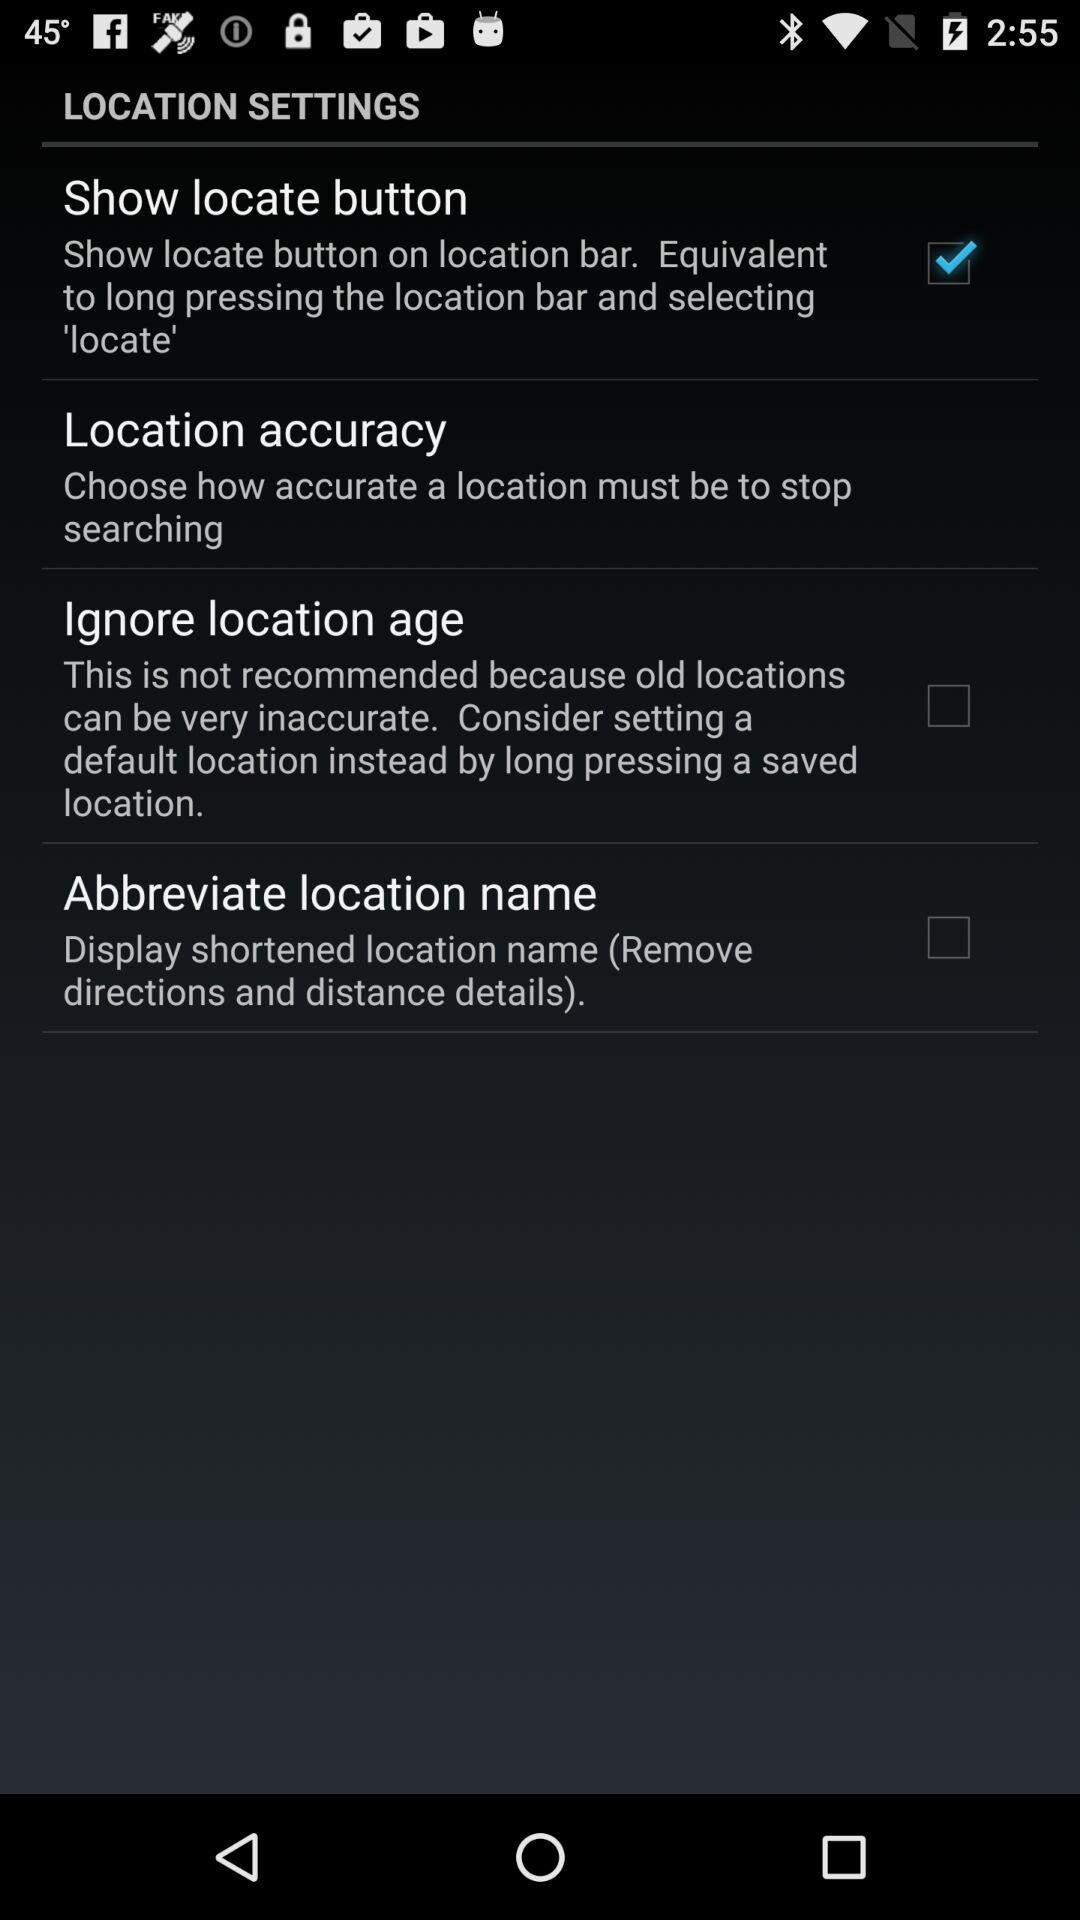What is the status of the location accuracy?
When the provided information is insufficient, respond with <no answer>. <no answer> 